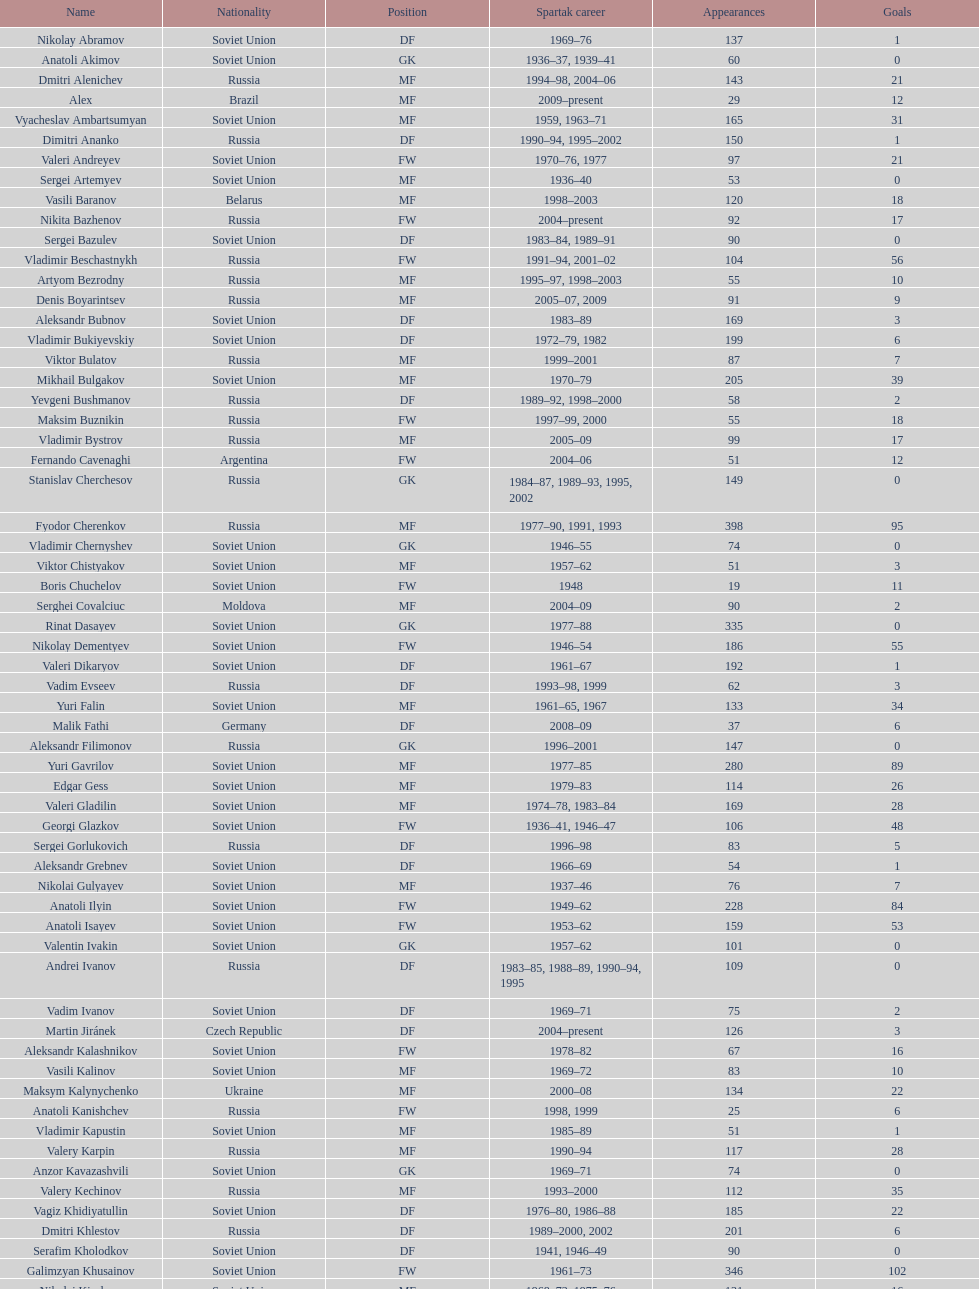Baranov has played from 2004 to the present. what is his nationality? Belarus. 